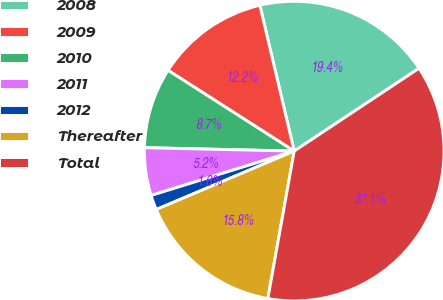Convert chart to OTSL. <chart><loc_0><loc_0><loc_500><loc_500><pie_chart><fcel>2008<fcel>2009<fcel>2010<fcel>2011<fcel>2012<fcel>Thereafter<fcel>Total<nl><fcel>19.36%<fcel>12.25%<fcel>8.7%<fcel>5.15%<fcel>1.59%<fcel>15.81%<fcel>37.14%<nl></chart> 